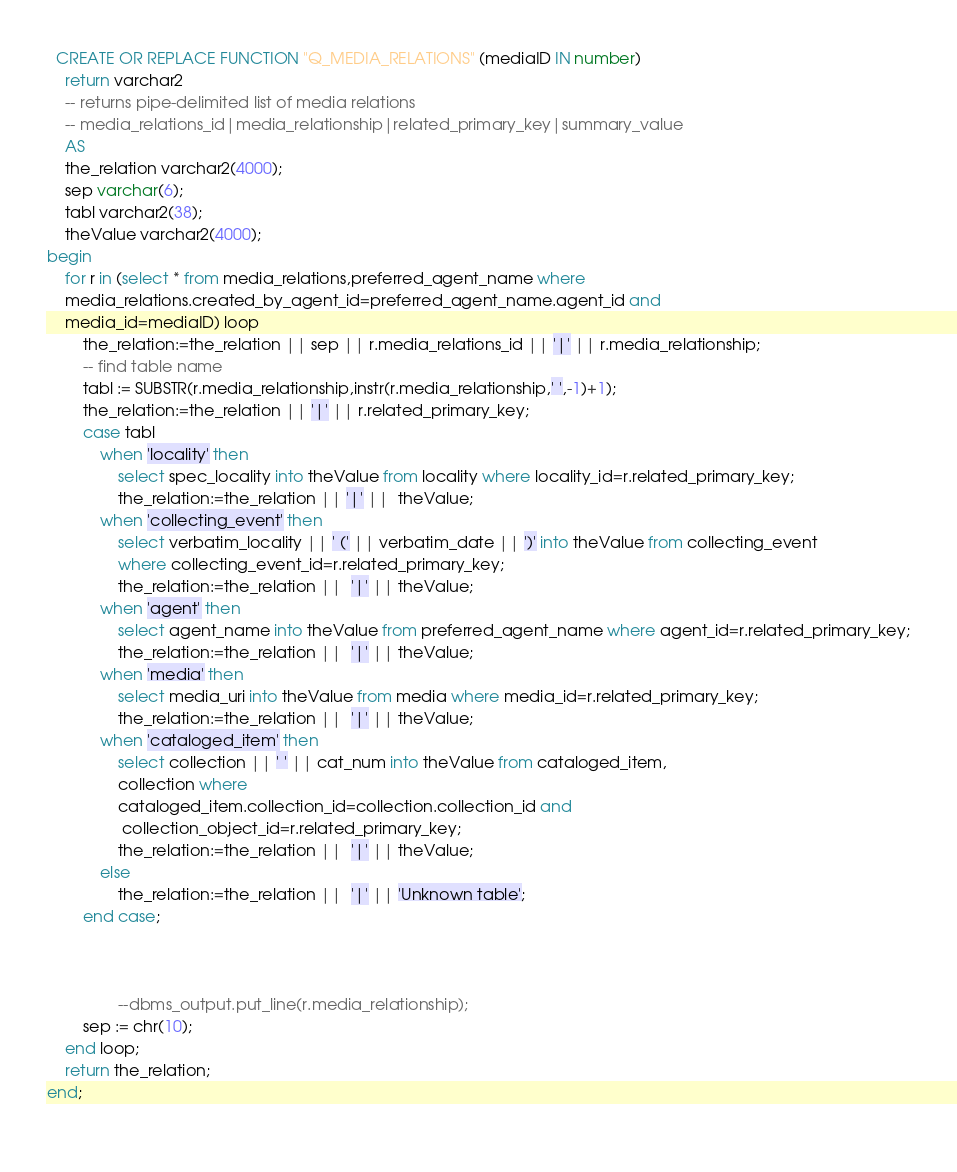Convert code to text. <code><loc_0><loc_0><loc_500><loc_500><_SQL_>
  CREATE OR REPLACE FUNCTION "Q_MEDIA_RELATIONS" (mediaID IN number)
	return varchar2
	-- returns pipe-delimited list of media relations
	-- media_relations_id|media_relationship|related_primary_key|summary_value
	AS
	the_relation varchar2(4000);
	sep varchar(6);
	tabl varchar2(38);
	theValue varchar2(4000);
begin
	for r in (select * from media_relations,preferred_agent_name where
	media_relations.created_by_agent_id=preferred_agent_name.agent_id and
	media_id=mediaID) loop
		the_relation:=the_relation || sep || r.media_relations_id || '|' || r.media_relationship;
		-- find table name
		tabl := SUBSTR(r.media_relationship,instr(r.media_relationship,' ',-1)+1);
		the_relation:=the_relation || '|' || r.related_primary_key;
		case tabl
			when 'locality' then
				select spec_locality into theValue from locality where locality_id=r.related_primary_key;
				the_relation:=the_relation || '|' ||  theValue;
			when 'collecting_event' then
				select verbatim_locality || ' (' || verbatim_date || ')' into theValue from collecting_event
				where collecting_event_id=r.related_primary_key;
				the_relation:=the_relation ||  '|' || theValue;
			when 'agent' then
				select agent_name into theValue from preferred_agent_name where agent_id=r.related_primary_key;
				the_relation:=the_relation ||  '|' || theValue;
			when 'media' then
				select media_uri into theValue from media where media_id=r.related_primary_key;
				the_relation:=the_relation ||  '|' || theValue;
			when 'cataloged_item' then
				select collection || ' ' || cat_num into theValue from cataloged_item,
				collection where
				cataloged_item.collection_id=collection.collection_id and
				 collection_object_id=r.related_primary_key;
				the_relation:=the_relation ||  '|' || theValue;
			else
				the_relation:=the_relation ||  '|' || 'Unknown table';
		end case;



				--dbms_output.put_line(r.media_relationship);
		sep := chr(10);
	end loop;
	return the_relation;
end;
 </code> 